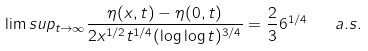<formula> <loc_0><loc_0><loc_500><loc_500>\lim s u p _ { t \to \infty } \frac { \eta ( x , t ) - \eta ( 0 , t ) } { 2 x ^ { 1 / 2 } t ^ { 1 / 4 } ( \log \log t ) ^ { 3 / 4 } } = \frac { 2 } { 3 } 6 ^ { 1 / 4 } \quad a . s .</formula> 